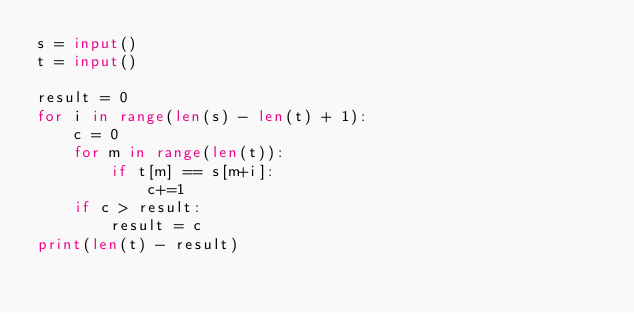<code> <loc_0><loc_0><loc_500><loc_500><_Python_>s = input()
t = input()

result = 0
for i in range(len(s) - len(t) + 1):
    c = 0
    for m in range(len(t)):
        if t[m] == s[m+i]:
            c+=1
    if c > result:
        result = c
print(len(t) - result)</code> 